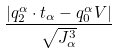Convert formula to latex. <formula><loc_0><loc_0><loc_500><loc_500>\frac { | q _ { 2 } ^ { \alpha } \cdot t _ { \alpha } - q _ { 0 } ^ { \alpha } V | } { \sqrt { J _ { \alpha } ^ { 3 } } }</formula> 